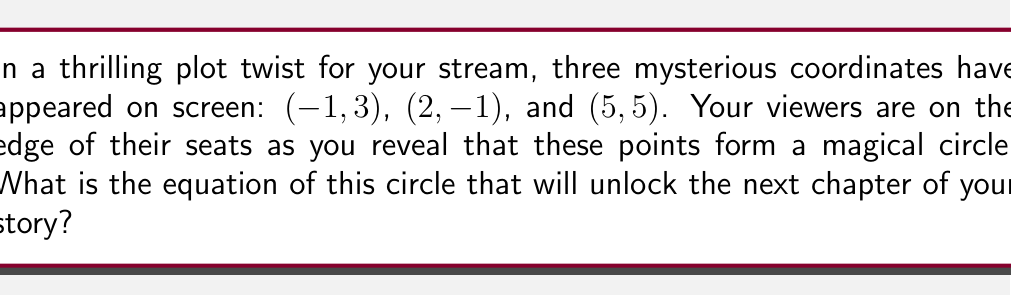Give your solution to this math problem. Let's solve this step-by-step:

1) The general equation of a circle is $(x-h)^2 + (y-k)^2 = r^2$, where $(h,k)$ is the center and $r$ is the radius.

2) To find the center and radius, we can use the general form of a circle equation:
   $x^2 + y^2 + Dx + Ey + F = 0$

3) Substitute the three given points into this equation:
   $(-1)^2 + 3^2 + D(-1) + E(3) + F = 0$
   $2^2 + (-1)^2 + D(2) + E(-1) + F = 0$
   $5^2 + 5^2 + D(5) + E(5) + F = 0$

4) Simplify:
   $1 + 9 - D + 3E + F = 0$
   $4 + 1 + 2D - E + F = 0$
   $25 + 25 + 5D + 5E + F = 0$

5) Subtract the first equation from the second:
   $-5 + 3D - 4E = 0$

6) Subtract the first equation from the third:
   $40 + 6D + 2E = 0$

7) Solve these two equations simultaneously:
   From (5): $3D - 4E = 5$
   From (6): $3D + E = -20$
   
   Subtracting these: $-5E = -25$
   Therefore, $E = 5$

   Substitute back: $3D + 5 = -20$
   Therefore, $D = -25/3$

8) Substitute $D$ and $E$ into any of the equations from step 4 to find $F$:
   $1 + 9 + 25/3 + 15 + F = 0$
   $F = -25/3 - 25 = -100/3$

9) Now we have $x^2 + y^2 - \frac{25}{3}x + 5y - \frac{100}{3} = 0$

10) To get this into standard form $(x-h)^2 + (y-k)^2 = r^2$:
    Complete the square for $x$ and $y$ terms:
    $(x^2 - \frac{25}{3}x + (\frac{25}{6})^2) + (y^2 + 5y + (\frac{5}{2})^2) = \frac{25}{36} + \frac{25}{4} + \frac{100}{3}$
    $(x - \frac{25}{6})^2 + (y + \frac{5}{2})^2 = \frac{169}{12}$

Therefore, the center is $(\frac{25}{6}, -\frac{5}{2})$ and the radius is $\sqrt{\frac{169}{12}}$.
Answer: The equation of the circle is $(x - \frac{25}{6})^2 + (y + \frac{5}{2})^2 = \frac{169}{12}$ 